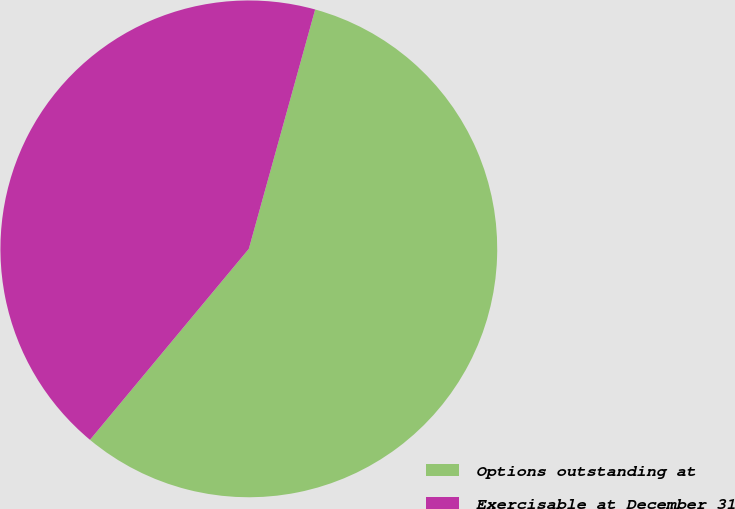Convert chart. <chart><loc_0><loc_0><loc_500><loc_500><pie_chart><fcel>Options outstanding at<fcel>Exercisable at December 31<nl><fcel>56.74%<fcel>43.26%<nl></chart> 